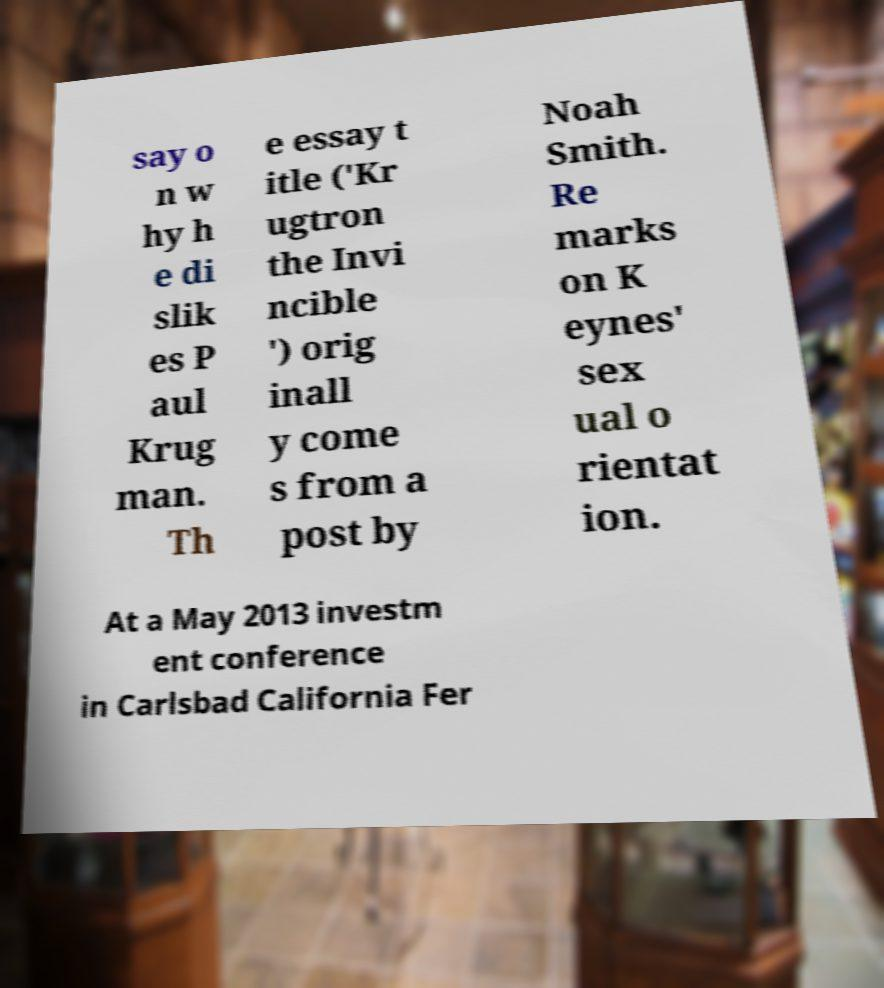There's text embedded in this image that I need extracted. Can you transcribe it verbatim? say o n w hy h e di slik es P aul Krug man. Th e essay t itle ('Kr ugtron the Invi ncible ') orig inall y come s from a post by Noah Smith. Re marks on K eynes' sex ual o rientat ion. At a May 2013 investm ent conference in Carlsbad California Fer 